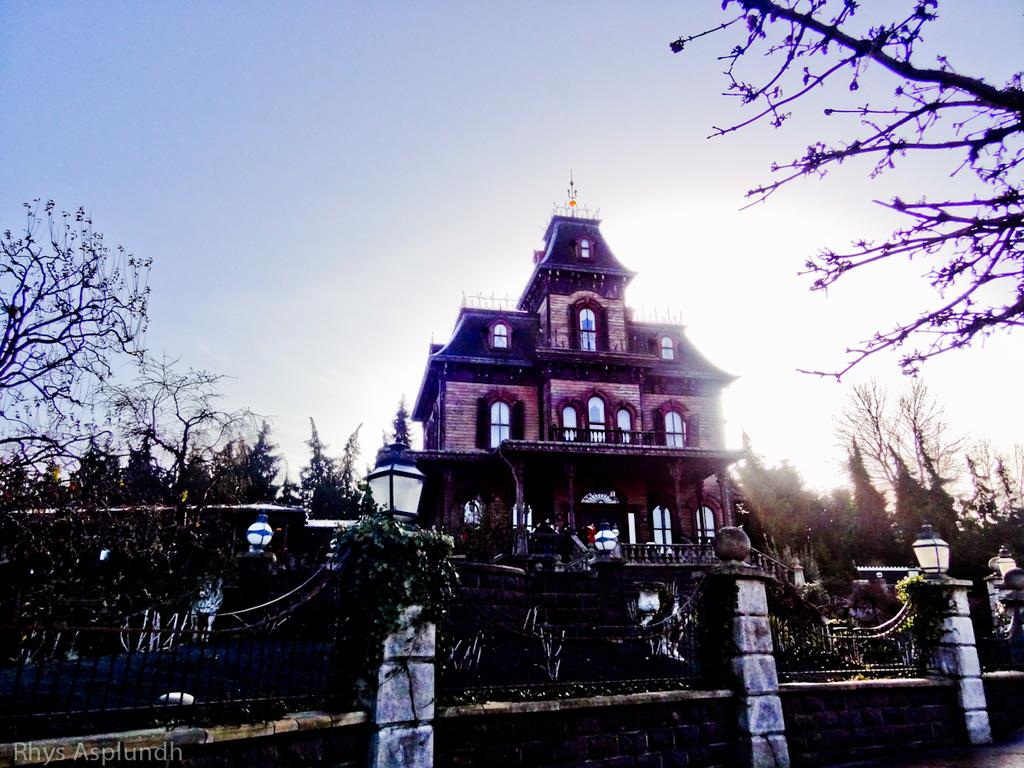What type of structure can be seen in the image? There is a rail in the image. What type of vegetation is visible on both sides of the image? Trees are visible on the left side and the right side of the image. What can be seen in the background of the image? There is a house and the sky visible in the background of the image. What type of knife is being used to cut the base in the image? There is no knife or base present in the image. What type of picture is hanging on the wall in the image? There is no picture or wall present in the image. 